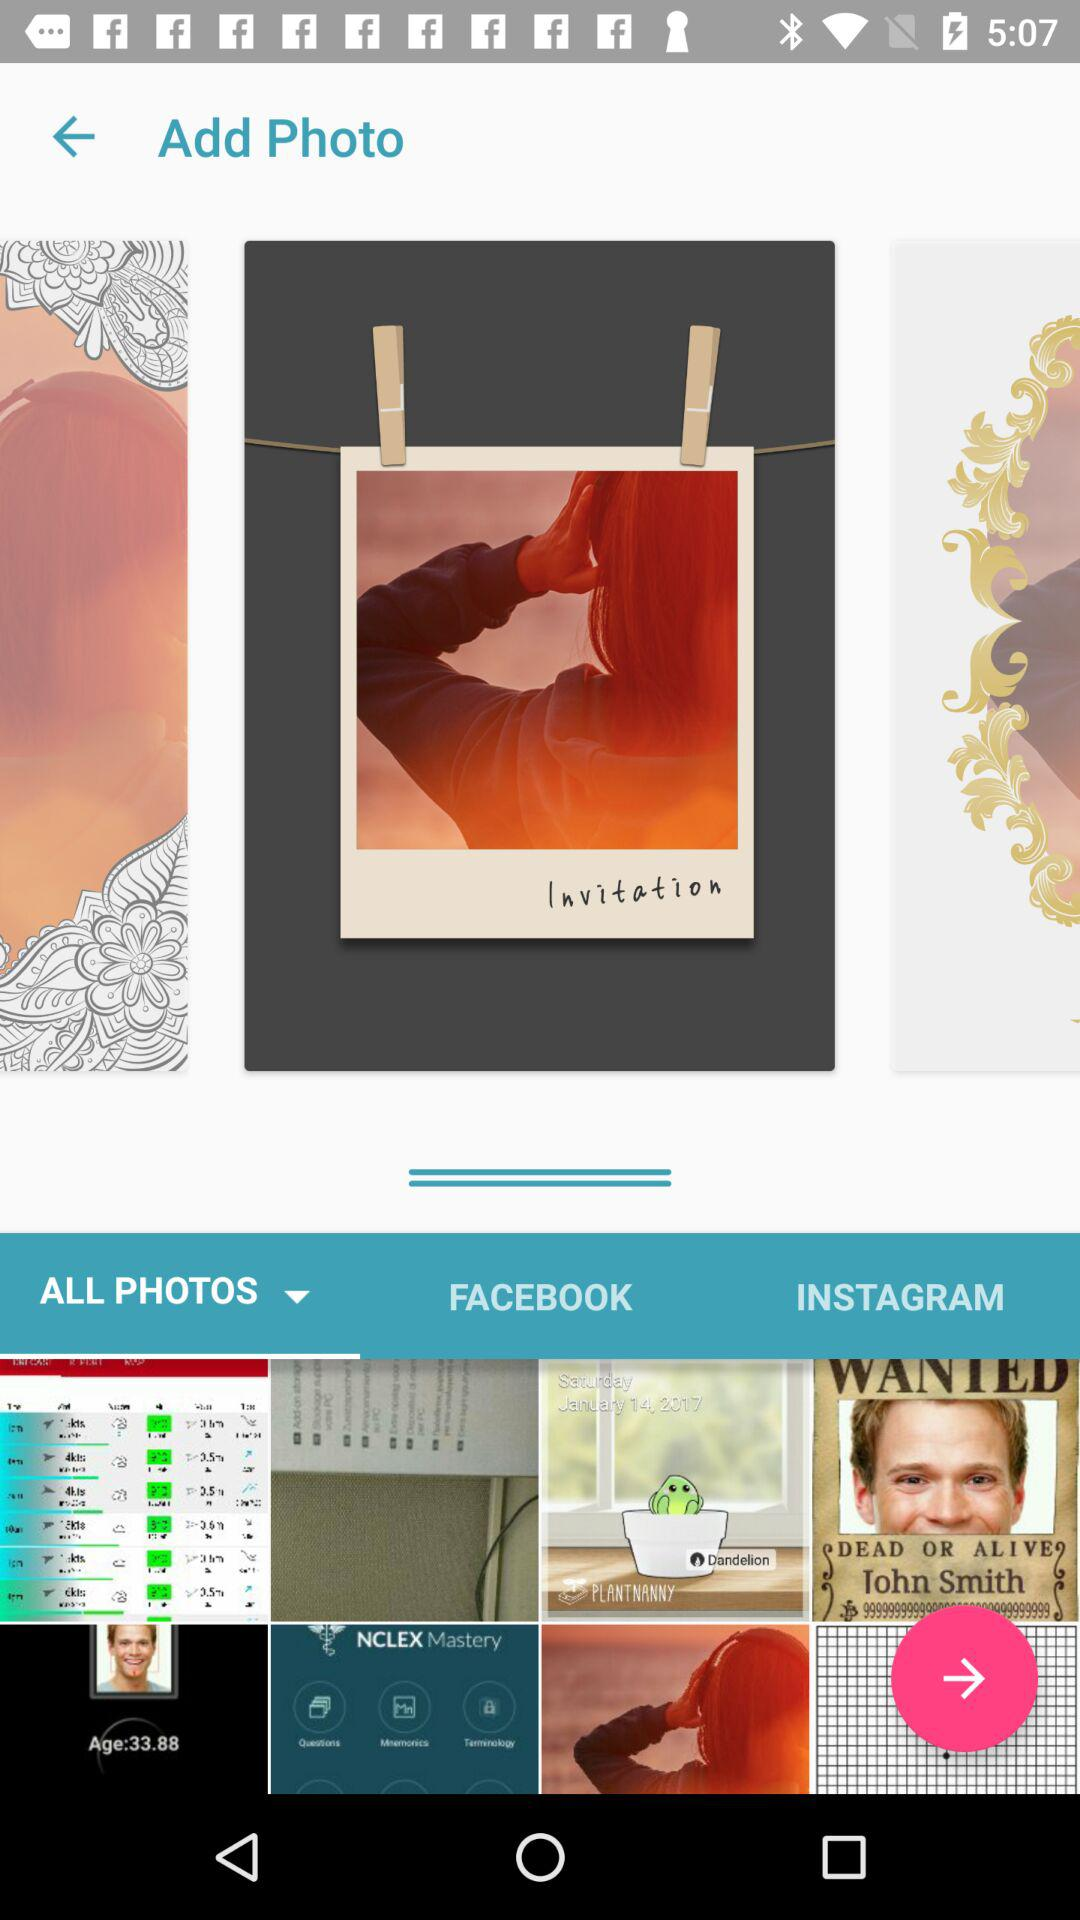Which tab is currently selected? The currently selected tab is "ALL PHOTOS". 